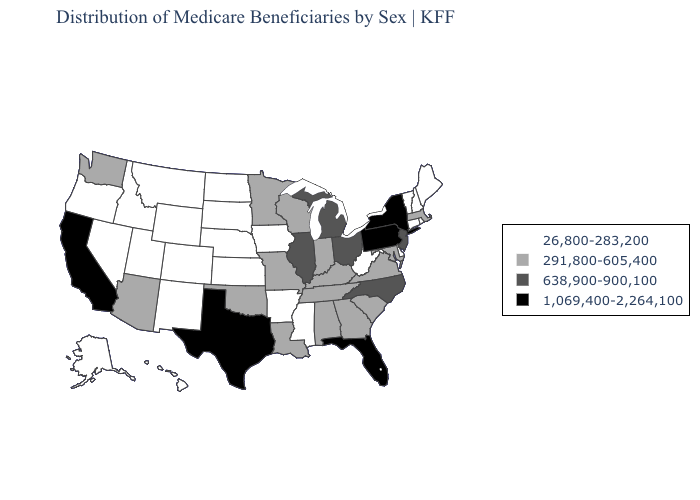What is the value of Alabama?
Write a very short answer. 291,800-605,400. What is the value of Montana?
Write a very short answer. 26,800-283,200. What is the highest value in the West ?
Be succinct. 1,069,400-2,264,100. Does Oklahoma have the highest value in the USA?
Write a very short answer. No. What is the value of Nevada?
Give a very brief answer. 26,800-283,200. Among the states that border Utah , which have the lowest value?
Quick response, please. Colorado, Idaho, Nevada, New Mexico, Wyoming. What is the lowest value in the USA?
Answer briefly. 26,800-283,200. What is the value of Minnesota?
Answer briefly. 291,800-605,400. Name the states that have a value in the range 1,069,400-2,264,100?
Short answer required. California, Florida, New York, Pennsylvania, Texas. Which states have the lowest value in the USA?
Quick response, please. Alaska, Arkansas, Colorado, Connecticut, Delaware, Hawaii, Idaho, Iowa, Kansas, Maine, Mississippi, Montana, Nebraska, Nevada, New Hampshire, New Mexico, North Dakota, Oregon, Rhode Island, South Dakota, Utah, Vermont, West Virginia, Wyoming. Does Virginia have the lowest value in the South?
Be succinct. No. Which states have the highest value in the USA?
Short answer required. California, Florida, New York, Pennsylvania, Texas. What is the value of Oklahoma?
Write a very short answer. 291,800-605,400. Name the states that have a value in the range 291,800-605,400?
Answer briefly. Alabama, Arizona, Georgia, Indiana, Kentucky, Louisiana, Maryland, Massachusetts, Minnesota, Missouri, Oklahoma, South Carolina, Tennessee, Virginia, Washington, Wisconsin. What is the highest value in states that border Georgia?
Quick response, please. 1,069,400-2,264,100. 